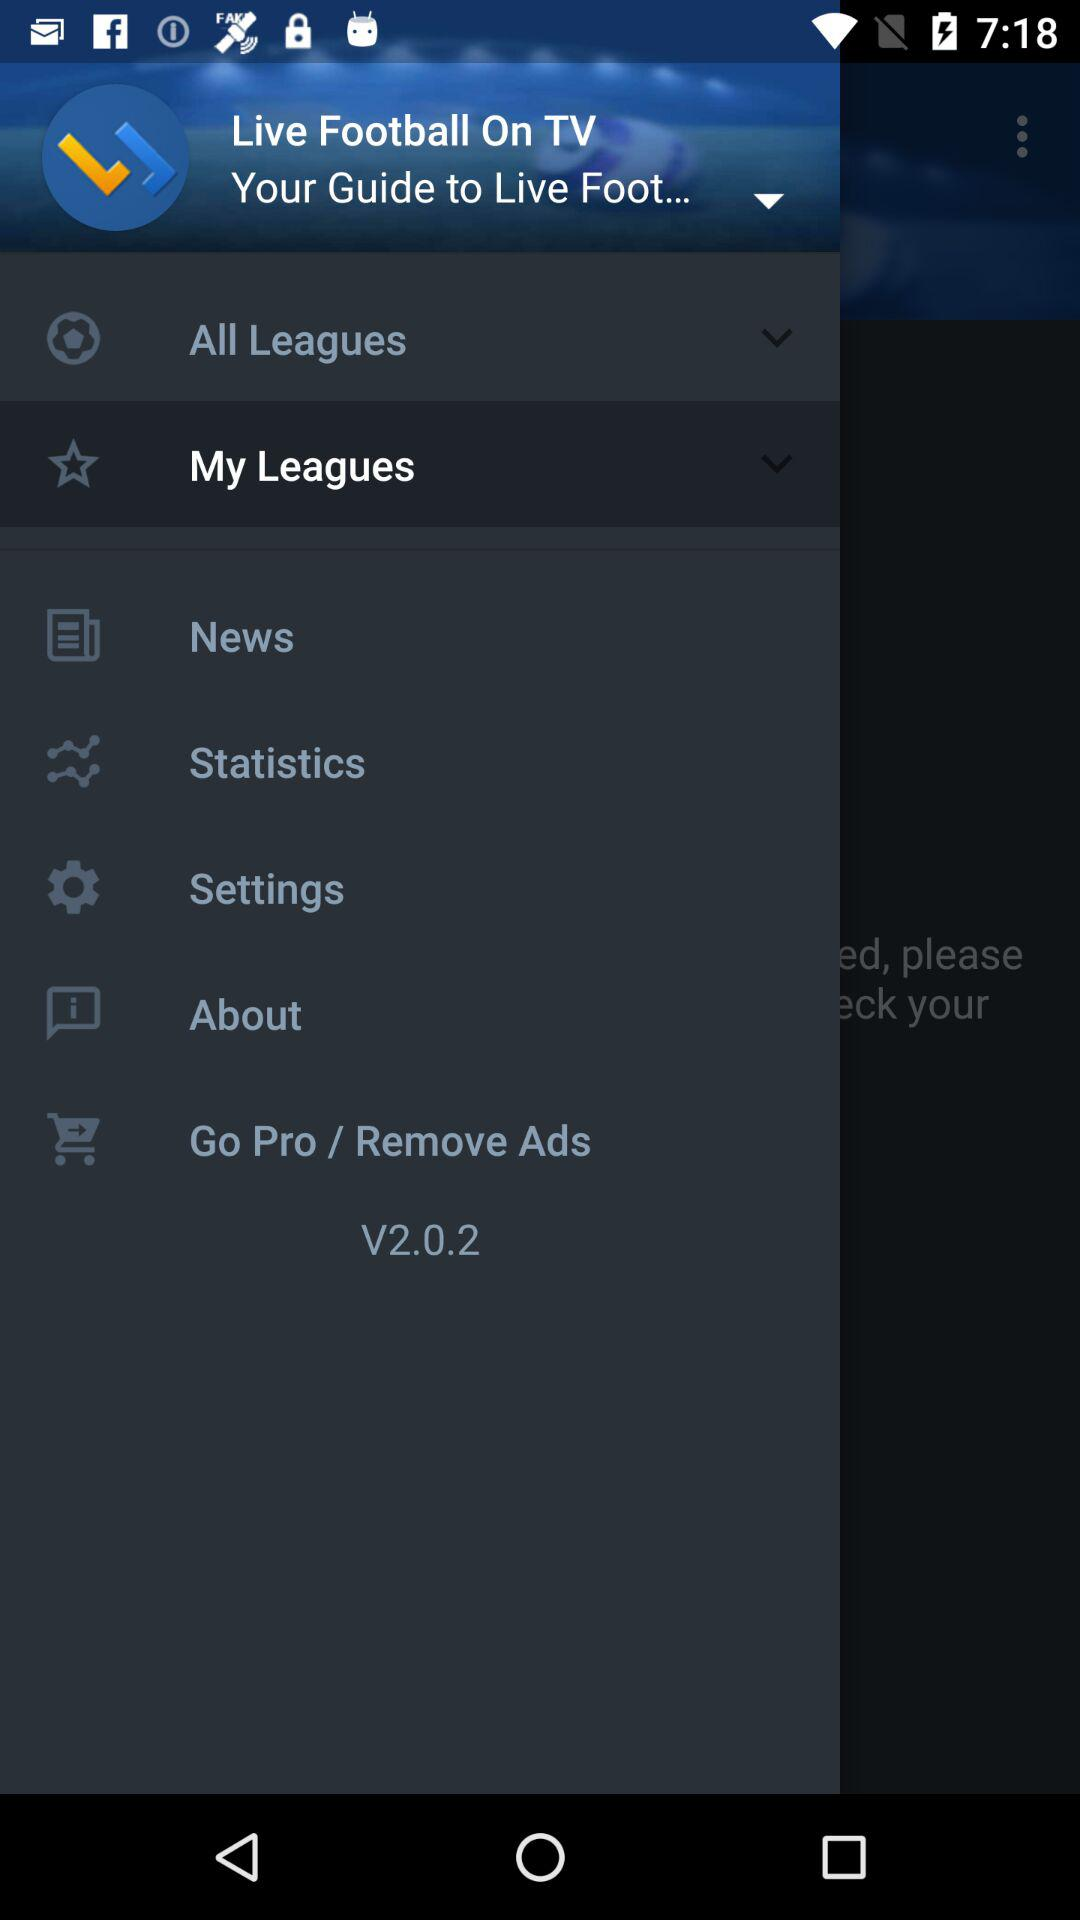What is the version of the app? The version is "V2.0.2". 